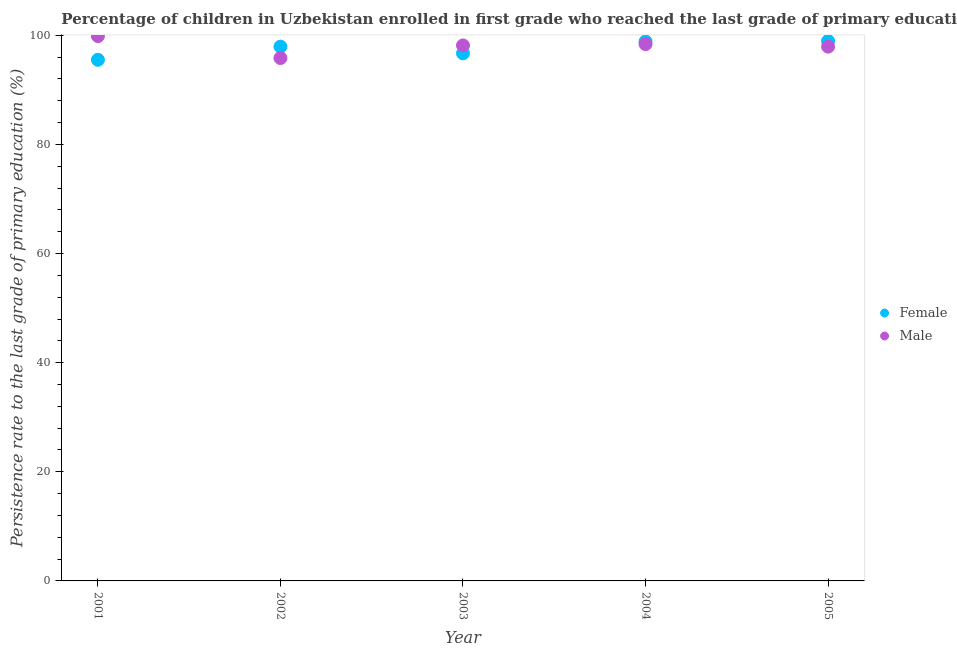What is the persistence rate of male students in 2002?
Ensure brevity in your answer.  95.84. Across all years, what is the maximum persistence rate of female students?
Give a very brief answer. 98.95. Across all years, what is the minimum persistence rate of female students?
Make the answer very short. 95.51. What is the total persistence rate of female students in the graph?
Keep it short and to the point. 487.94. What is the difference between the persistence rate of male students in 2001 and that in 2004?
Your answer should be very brief. 1.47. What is the difference between the persistence rate of female students in 2003 and the persistence rate of male students in 2004?
Give a very brief answer. -1.69. What is the average persistence rate of male students per year?
Offer a terse response. 98.03. In the year 2004, what is the difference between the persistence rate of male students and persistence rate of female students?
Provide a short and direct response. -0.47. In how many years, is the persistence rate of male students greater than 64 %?
Your answer should be compact. 5. What is the ratio of the persistence rate of male students in 2003 to that in 2005?
Make the answer very short. 1. Is the difference between the persistence rate of female students in 2001 and 2005 greater than the difference between the persistence rate of male students in 2001 and 2005?
Ensure brevity in your answer.  No. What is the difference between the highest and the second highest persistence rate of male students?
Make the answer very short. 1.47. What is the difference between the highest and the lowest persistence rate of female students?
Make the answer very short. 3.44. Is the persistence rate of female students strictly less than the persistence rate of male students over the years?
Your response must be concise. No. How many dotlines are there?
Keep it short and to the point. 2. What is the difference between two consecutive major ticks on the Y-axis?
Offer a terse response. 20. Does the graph contain any zero values?
Provide a short and direct response. No. Where does the legend appear in the graph?
Provide a succinct answer. Center right. How many legend labels are there?
Ensure brevity in your answer.  2. How are the legend labels stacked?
Keep it short and to the point. Vertical. What is the title of the graph?
Provide a succinct answer. Percentage of children in Uzbekistan enrolled in first grade who reached the last grade of primary education. What is the label or title of the X-axis?
Your answer should be very brief. Year. What is the label or title of the Y-axis?
Make the answer very short. Persistence rate to the last grade of primary education (%). What is the Persistence rate to the last grade of primary education (%) of Female in 2001?
Keep it short and to the point. 95.51. What is the Persistence rate to the last grade of primary education (%) of Male in 2001?
Keep it short and to the point. 99.86. What is the Persistence rate to the last grade of primary education (%) of Female in 2002?
Offer a terse response. 97.92. What is the Persistence rate to the last grade of primary education (%) of Male in 2002?
Offer a terse response. 95.84. What is the Persistence rate to the last grade of primary education (%) in Female in 2003?
Offer a terse response. 96.69. What is the Persistence rate to the last grade of primary education (%) of Male in 2003?
Your answer should be very brief. 98.15. What is the Persistence rate to the last grade of primary education (%) in Female in 2004?
Your answer should be compact. 98.86. What is the Persistence rate to the last grade of primary education (%) in Male in 2004?
Give a very brief answer. 98.39. What is the Persistence rate to the last grade of primary education (%) in Female in 2005?
Offer a very short reply. 98.95. What is the Persistence rate to the last grade of primary education (%) in Male in 2005?
Make the answer very short. 97.93. Across all years, what is the maximum Persistence rate to the last grade of primary education (%) in Female?
Your answer should be compact. 98.95. Across all years, what is the maximum Persistence rate to the last grade of primary education (%) of Male?
Give a very brief answer. 99.86. Across all years, what is the minimum Persistence rate to the last grade of primary education (%) of Female?
Your answer should be very brief. 95.51. Across all years, what is the minimum Persistence rate to the last grade of primary education (%) in Male?
Offer a very short reply. 95.84. What is the total Persistence rate to the last grade of primary education (%) in Female in the graph?
Provide a short and direct response. 487.94. What is the total Persistence rate to the last grade of primary education (%) in Male in the graph?
Ensure brevity in your answer.  490.16. What is the difference between the Persistence rate to the last grade of primary education (%) in Female in 2001 and that in 2002?
Give a very brief answer. -2.4. What is the difference between the Persistence rate to the last grade of primary education (%) in Male in 2001 and that in 2002?
Make the answer very short. 4.02. What is the difference between the Persistence rate to the last grade of primary education (%) in Female in 2001 and that in 2003?
Your answer should be compact. -1.18. What is the difference between the Persistence rate to the last grade of primary education (%) in Male in 2001 and that in 2003?
Provide a short and direct response. 1.72. What is the difference between the Persistence rate to the last grade of primary education (%) of Female in 2001 and that in 2004?
Give a very brief answer. -3.35. What is the difference between the Persistence rate to the last grade of primary education (%) in Male in 2001 and that in 2004?
Provide a short and direct response. 1.47. What is the difference between the Persistence rate to the last grade of primary education (%) of Female in 2001 and that in 2005?
Your answer should be very brief. -3.44. What is the difference between the Persistence rate to the last grade of primary education (%) of Male in 2001 and that in 2005?
Offer a terse response. 1.94. What is the difference between the Persistence rate to the last grade of primary education (%) of Female in 2002 and that in 2003?
Give a very brief answer. 1.22. What is the difference between the Persistence rate to the last grade of primary education (%) of Male in 2002 and that in 2003?
Offer a terse response. -2.31. What is the difference between the Persistence rate to the last grade of primary education (%) in Female in 2002 and that in 2004?
Make the answer very short. -0.94. What is the difference between the Persistence rate to the last grade of primary education (%) of Male in 2002 and that in 2004?
Give a very brief answer. -2.55. What is the difference between the Persistence rate to the last grade of primary education (%) of Female in 2002 and that in 2005?
Offer a terse response. -1.04. What is the difference between the Persistence rate to the last grade of primary education (%) in Male in 2002 and that in 2005?
Ensure brevity in your answer.  -2.09. What is the difference between the Persistence rate to the last grade of primary education (%) in Female in 2003 and that in 2004?
Give a very brief answer. -2.17. What is the difference between the Persistence rate to the last grade of primary education (%) in Male in 2003 and that in 2004?
Give a very brief answer. -0.24. What is the difference between the Persistence rate to the last grade of primary education (%) in Female in 2003 and that in 2005?
Your answer should be compact. -2.26. What is the difference between the Persistence rate to the last grade of primary education (%) of Male in 2003 and that in 2005?
Offer a terse response. 0.22. What is the difference between the Persistence rate to the last grade of primary education (%) in Female in 2004 and that in 2005?
Keep it short and to the point. -0.09. What is the difference between the Persistence rate to the last grade of primary education (%) of Male in 2004 and that in 2005?
Your answer should be compact. 0.46. What is the difference between the Persistence rate to the last grade of primary education (%) of Female in 2001 and the Persistence rate to the last grade of primary education (%) of Male in 2002?
Offer a terse response. -0.32. What is the difference between the Persistence rate to the last grade of primary education (%) of Female in 2001 and the Persistence rate to the last grade of primary education (%) of Male in 2003?
Give a very brief answer. -2.63. What is the difference between the Persistence rate to the last grade of primary education (%) of Female in 2001 and the Persistence rate to the last grade of primary education (%) of Male in 2004?
Give a very brief answer. -2.87. What is the difference between the Persistence rate to the last grade of primary education (%) of Female in 2001 and the Persistence rate to the last grade of primary education (%) of Male in 2005?
Provide a succinct answer. -2.41. What is the difference between the Persistence rate to the last grade of primary education (%) in Female in 2002 and the Persistence rate to the last grade of primary education (%) in Male in 2003?
Offer a terse response. -0.23. What is the difference between the Persistence rate to the last grade of primary education (%) of Female in 2002 and the Persistence rate to the last grade of primary education (%) of Male in 2004?
Provide a short and direct response. -0.47. What is the difference between the Persistence rate to the last grade of primary education (%) in Female in 2002 and the Persistence rate to the last grade of primary education (%) in Male in 2005?
Provide a succinct answer. -0.01. What is the difference between the Persistence rate to the last grade of primary education (%) of Female in 2003 and the Persistence rate to the last grade of primary education (%) of Male in 2004?
Offer a terse response. -1.69. What is the difference between the Persistence rate to the last grade of primary education (%) in Female in 2003 and the Persistence rate to the last grade of primary education (%) in Male in 2005?
Your answer should be compact. -1.23. What is the difference between the Persistence rate to the last grade of primary education (%) of Female in 2004 and the Persistence rate to the last grade of primary education (%) of Male in 2005?
Offer a terse response. 0.93. What is the average Persistence rate to the last grade of primary education (%) in Female per year?
Offer a terse response. 97.59. What is the average Persistence rate to the last grade of primary education (%) of Male per year?
Your response must be concise. 98.03. In the year 2001, what is the difference between the Persistence rate to the last grade of primary education (%) in Female and Persistence rate to the last grade of primary education (%) in Male?
Ensure brevity in your answer.  -4.35. In the year 2002, what is the difference between the Persistence rate to the last grade of primary education (%) of Female and Persistence rate to the last grade of primary education (%) of Male?
Ensure brevity in your answer.  2.08. In the year 2003, what is the difference between the Persistence rate to the last grade of primary education (%) in Female and Persistence rate to the last grade of primary education (%) in Male?
Your response must be concise. -1.45. In the year 2004, what is the difference between the Persistence rate to the last grade of primary education (%) in Female and Persistence rate to the last grade of primary education (%) in Male?
Your answer should be very brief. 0.47. In the year 2005, what is the difference between the Persistence rate to the last grade of primary education (%) of Female and Persistence rate to the last grade of primary education (%) of Male?
Ensure brevity in your answer.  1.03. What is the ratio of the Persistence rate to the last grade of primary education (%) in Female in 2001 to that in 2002?
Keep it short and to the point. 0.98. What is the ratio of the Persistence rate to the last grade of primary education (%) in Male in 2001 to that in 2002?
Offer a terse response. 1.04. What is the ratio of the Persistence rate to the last grade of primary education (%) of Male in 2001 to that in 2003?
Offer a terse response. 1.02. What is the ratio of the Persistence rate to the last grade of primary education (%) of Female in 2001 to that in 2004?
Offer a terse response. 0.97. What is the ratio of the Persistence rate to the last grade of primary education (%) of Male in 2001 to that in 2004?
Your answer should be very brief. 1.01. What is the ratio of the Persistence rate to the last grade of primary education (%) in Female in 2001 to that in 2005?
Ensure brevity in your answer.  0.97. What is the ratio of the Persistence rate to the last grade of primary education (%) of Male in 2001 to that in 2005?
Your response must be concise. 1.02. What is the ratio of the Persistence rate to the last grade of primary education (%) in Female in 2002 to that in 2003?
Provide a succinct answer. 1.01. What is the ratio of the Persistence rate to the last grade of primary education (%) of Male in 2002 to that in 2003?
Offer a terse response. 0.98. What is the ratio of the Persistence rate to the last grade of primary education (%) in Male in 2002 to that in 2004?
Your answer should be compact. 0.97. What is the ratio of the Persistence rate to the last grade of primary education (%) of Female in 2002 to that in 2005?
Provide a short and direct response. 0.99. What is the ratio of the Persistence rate to the last grade of primary education (%) of Male in 2002 to that in 2005?
Offer a very short reply. 0.98. What is the ratio of the Persistence rate to the last grade of primary education (%) of Female in 2003 to that in 2004?
Give a very brief answer. 0.98. What is the ratio of the Persistence rate to the last grade of primary education (%) of Male in 2003 to that in 2004?
Offer a very short reply. 1. What is the ratio of the Persistence rate to the last grade of primary education (%) in Female in 2003 to that in 2005?
Your answer should be compact. 0.98. What is the ratio of the Persistence rate to the last grade of primary education (%) of Female in 2004 to that in 2005?
Offer a terse response. 1. What is the difference between the highest and the second highest Persistence rate to the last grade of primary education (%) of Female?
Provide a succinct answer. 0.09. What is the difference between the highest and the second highest Persistence rate to the last grade of primary education (%) of Male?
Your answer should be compact. 1.47. What is the difference between the highest and the lowest Persistence rate to the last grade of primary education (%) in Female?
Make the answer very short. 3.44. What is the difference between the highest and the lowest Persistence rate to the last grade of primary education (%) of Male?
Give a very brief answer. 4.02. 